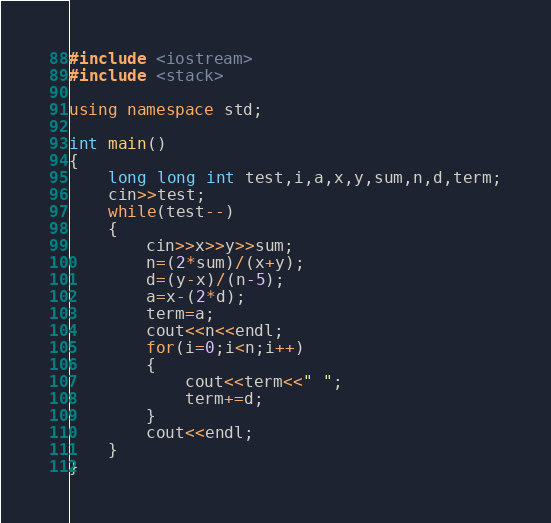<code> <loc_0><loc_0><loc_500><loc_500><_C++_>#include <iostream>
#include <stack>

using namespace std;

int main()
{
    long long int test,i,a,x,y,sum,n,d,term;
    cin>>test;
    while(test--)
    {
        cin>>x>>y>>sum;
        n=(2*sum)/(x+y);
        d=(y-x)/(n-5);
        a=x-(2*d);
        term=a;
        cout<<n<<endl;
        for(i=0;i<n;i++)
        {
            cout<<term<<" ";
            term+=d;
        }
        cout<<endl;
    }
}
</code> 